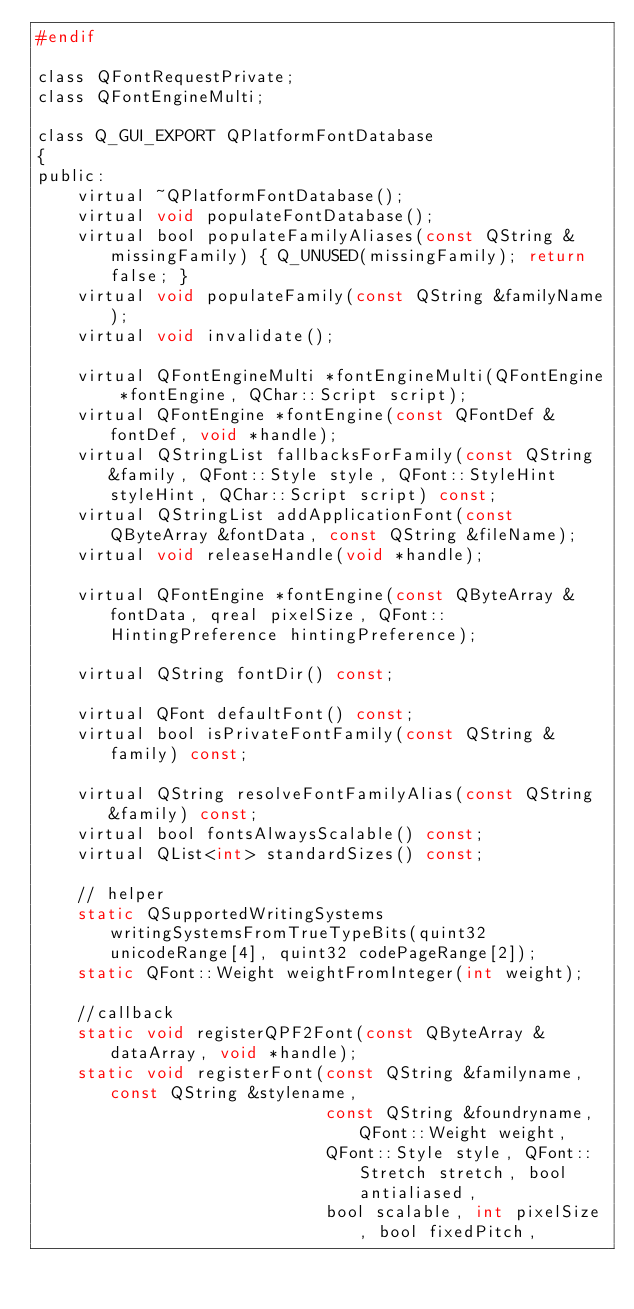Convert code to text. <code><loc_0><loc_0><loc_500><loc_500><_C_>#endif

class QFontRequestPrivate;
class QFontEngineMulti;

class Q_GUI_EXPORT QPlatformFontDatabase
{
public:
    virtual ~QPlatformFontDatabase();
    virtual void populateFontDatabase();
    virtual bool populateFamilyAliases(const QString &missingFamily) { Q_UNUSED(missingFamily); return false; }
    virtual void populateFamily(const QString &familyName);
    virtual void invalidate();

    virtual QFontEngineMulti *fontEngineMulti(QFontEngine *fontEngine, QChar::Script script);
    virtual QFontEngine *fontEngine(const QFontDef &fontDef, void *handle);
    virtual QStringList fallbacksForFamily(const QString &family, QFont::Style style, QFont::StyleHint styleHint, QChar::Script script) const;
    virtual QStringList addApplicationFont(const QByteArray &fontData, const QString &fileName);
    virtual void releaseHandle(void *handle);

    virtual QFontEngine *fontEngine(const QByteArray &fontData, qreal pixelSize, QFont::HintingPreference hintingPreference);

    virtual QString fontDir() const;

    virtual QFont defaultFont() const;
    virtual bool isPrivateFontFamily(const QString &family) const;

    virtual QString resolveFontFamilyAlias(const QString &family) const;
    virtual bool fontsAlwaysScalable() const;
    virtual QList<int> standardSizes() const;

    // helper
    static QSupportedWritingSystems writingSystemsFromTrueTypeBits(quint32 unicodeRange[4], quint32 codePageRange[2]);
    static QFont::Weight weightFromInteger(int weight);

    //callback
    static void registerQPF2Font(const QByteArray &dataArray, void *handle);
    static void registerFont(const QString &familyname, const QString &stylename,
                             const QString &foundryname, QFont::Weight weight,
                             QFont::Style style, QFont::Stretch stretch, bool antialiased,
                             bool scalable, int pixelSize, bool fixedPitch,</code> 